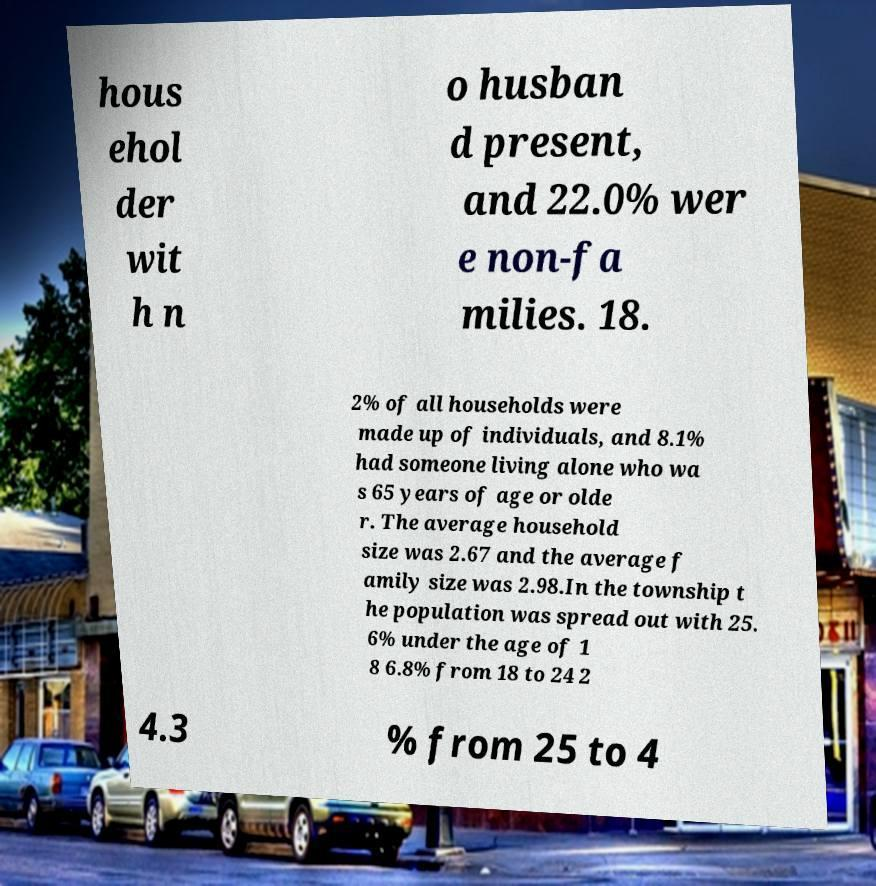Can you accurately transcribe the text from the provided image for me? hous ehol der wit h n o husban d present, and 22.0% wer e non-fa milies. 18. 2% of all households were made up of individuals, and 8.1% had someone living alone who wa s 65 years of age or olde r. The average household size was 2.67 and the average f amily size was 2.98.In the township t he population was spread out with 25. 6% under the age of 1 8 6.8% from 18 to 24 2 4.3 % from 25 to 4 